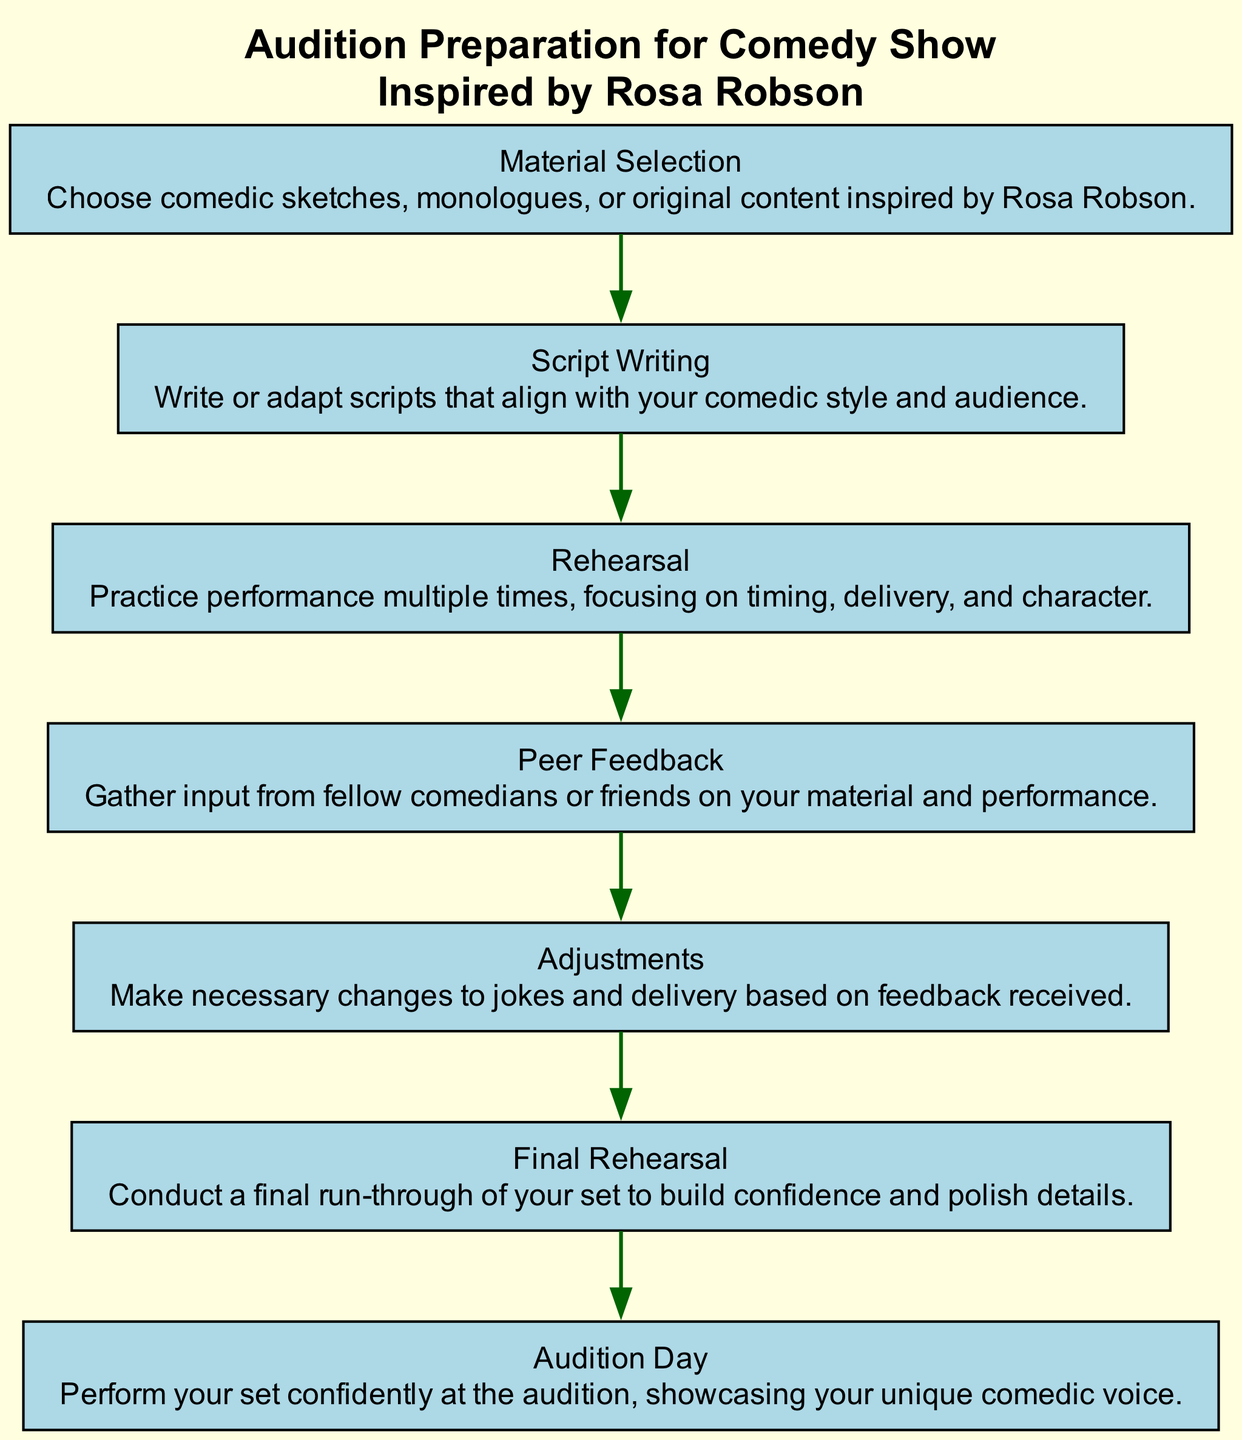What is the first step in the audition preparation process? The diagram starts with "Material Selection," indicating it is the first node in the flow.
Answer: Material Selection How many nodes are there in the diagram? The diagram lists a total of 7 elements or nodes, as specified in the provided data.
Answer: 7 What comes after "Script Writing"? "Practice" follows "Script Writing," directly connecting these two nodes in sequence according to the diagram.
Answer: Rehearsal What is the last step before "Audition Day"? The step right before "Audition Day" is "Final Rehearsal," indicating it is the preparation performed immediately prior to the audition.
Answer: Final Rehearsal Which step involves gathering input from others? The node "Peer Feedback" specifically addresses the process of collecting feedback from fellow comedians or friends.
Answer: Peer Feedback How many steps are there from "Material Selection" to "Audition Day"? Counting the steps sequentially from "Material Selection" to "Audition Day", there are 6 steps in total, including all nodes in between.
Answer: 6 What type of content should be selected in the "Material Selection" step? The description under "Material Selection" specifies selecting comedic sketches, monologues, or original content inspired by Rosa Robson.
Answer: Comedic sketches, monologues, or original content inspired by Rosa Robson Which step emphasizes polishing performance details? The "Final Rehearsal" step focuses on the final run-through to build confidence and polish overall performance details.
Answer: Final Rehearsal 